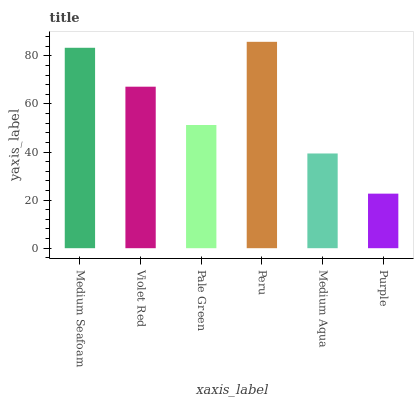Is Violet Red the minimum?
Answer yes or no. No. Is Violet Red the maximum?
Answer yes or no. No. Is Medium Seafoam greater than Violet Red?
Answer yes or no. Yes. Is Violet Red less than Medium Seafoam?
Answer yes or no. Yes. Is Violet Red greater than Medium Seafoam?
Answer yes or no. No. Is Medium Seafoam less than Violet Red?
Answer yes or no. No. Is Violet Red the high median?
Answer yes or no. Yes. Is Pale Green the low median?
Answer yes or no. Yes. Is Medium Aqua the high median?
Answer yes or no. No. Is Purple the low median?
Answer yes or no. No. 